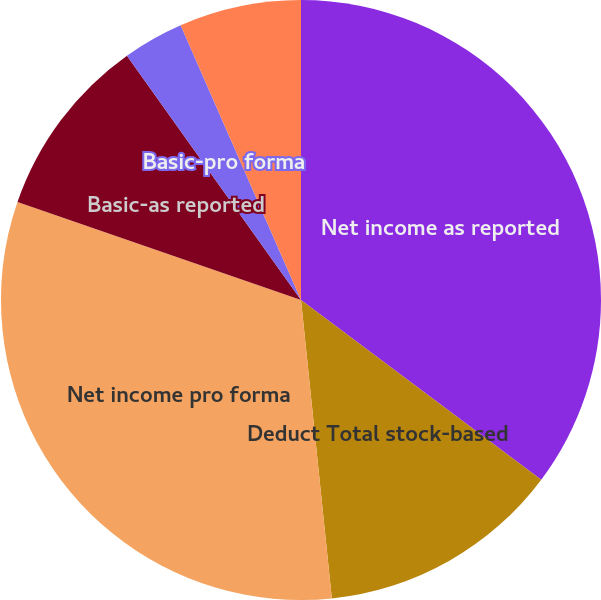Convert chart. <chart><loc_0><loc_0><loc_500><loc_500><pie_chart><fcel>Net income as reported<fcel>Deduct Total stock-based<fcel>Net income pro forma<fcel>Basic-as reported<fcel>Basic-pro forma<fcel>Diluted-as reported<fcel>Diluted-pro forma<nl><fcel>35.22%<fcel>13.14%<fcel>31.94%<fcel>9.85%<fcel>3.28%<fcel>6.57%<fcel>0.0%<nl></chart> 